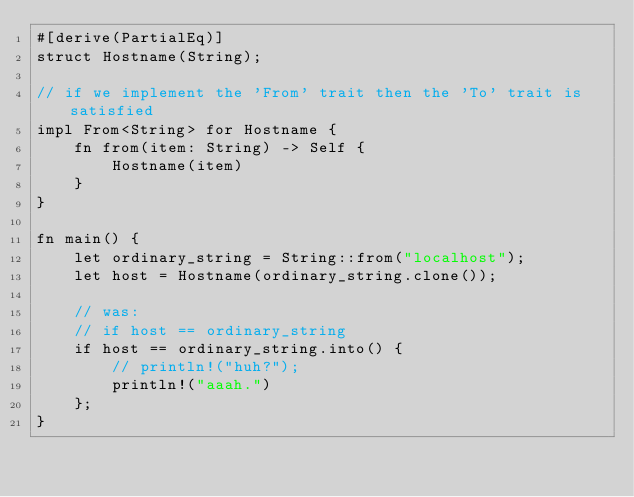<code> <loc_0><loc_0><loc_500><loc_500><_Rust_>#[derive(PartialEq)]
struct Hostname(String);

// if we implement the 'From' trait then the 'To' trait is satisfied
impl From<String> for Hostname {
    fn from(item: String) -> Self {
        Hostname(item)
    }
}

fn main() {
    let ordinary_string = String::from("localhost");
    let host = Hostname(ordinary_string.clone());

    // was:
    // if host == ordinary_string
    if host == ordinary_string.into() {
        // println!("huh?");
        println!("aaah.")
    };
}
</code> 